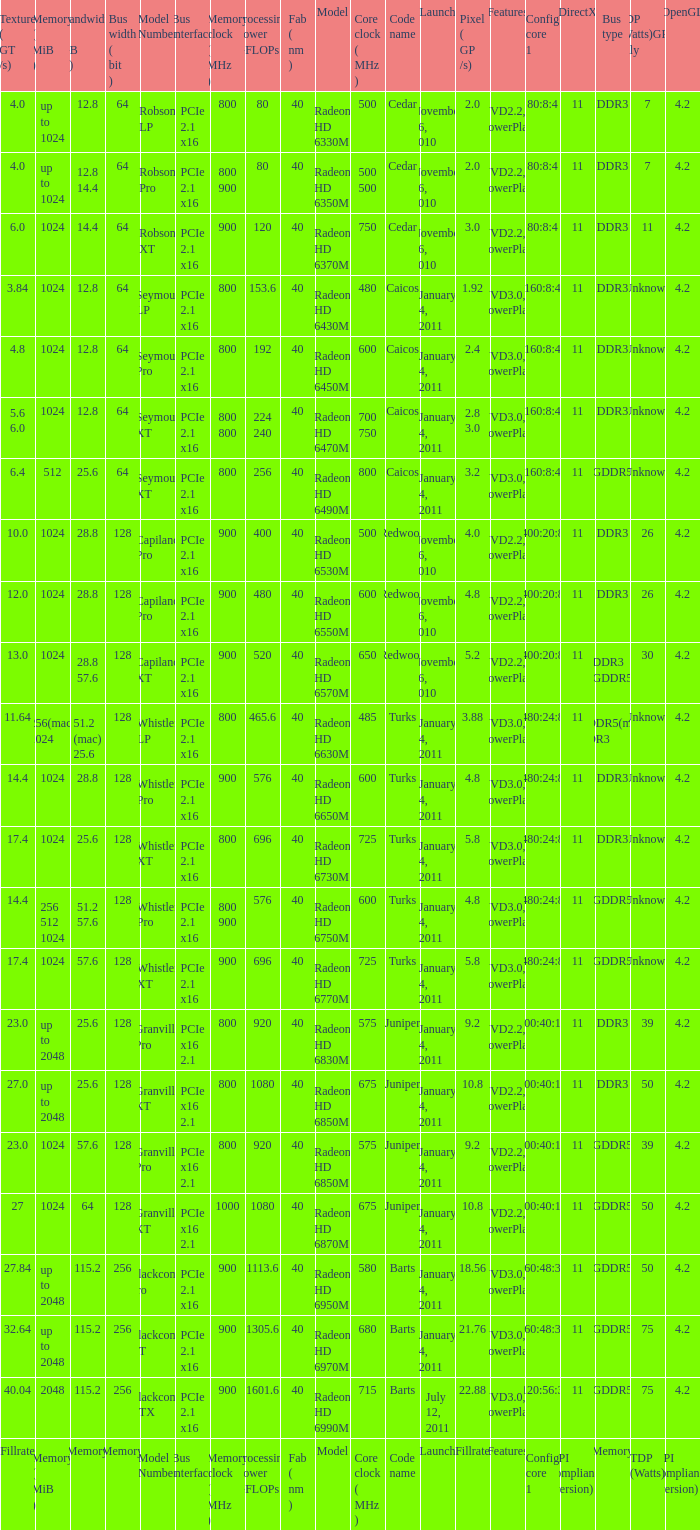How many values for fab(nm) if the model number is Whistler LP? 1.0. 